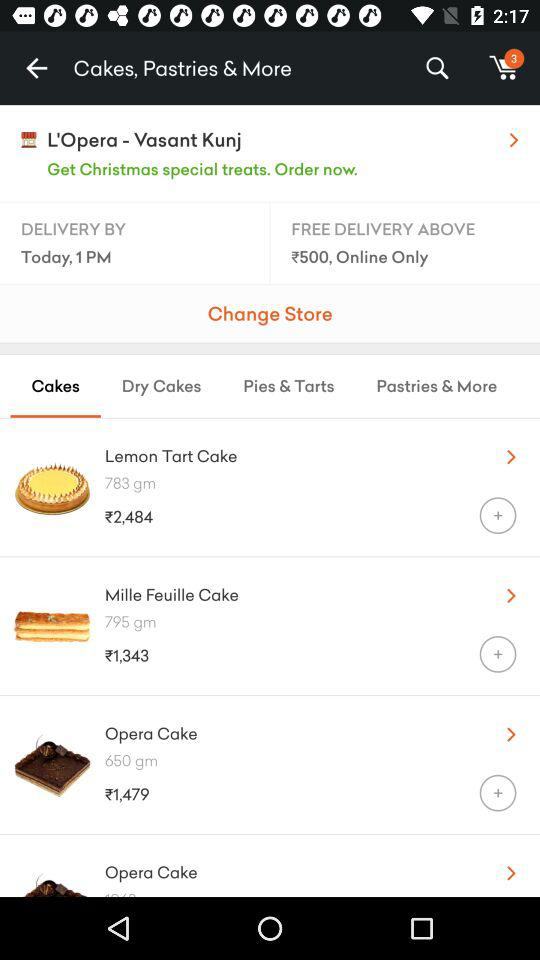How many items are there in the shopping cart?
Answer the question using a single word or phrase. 3 